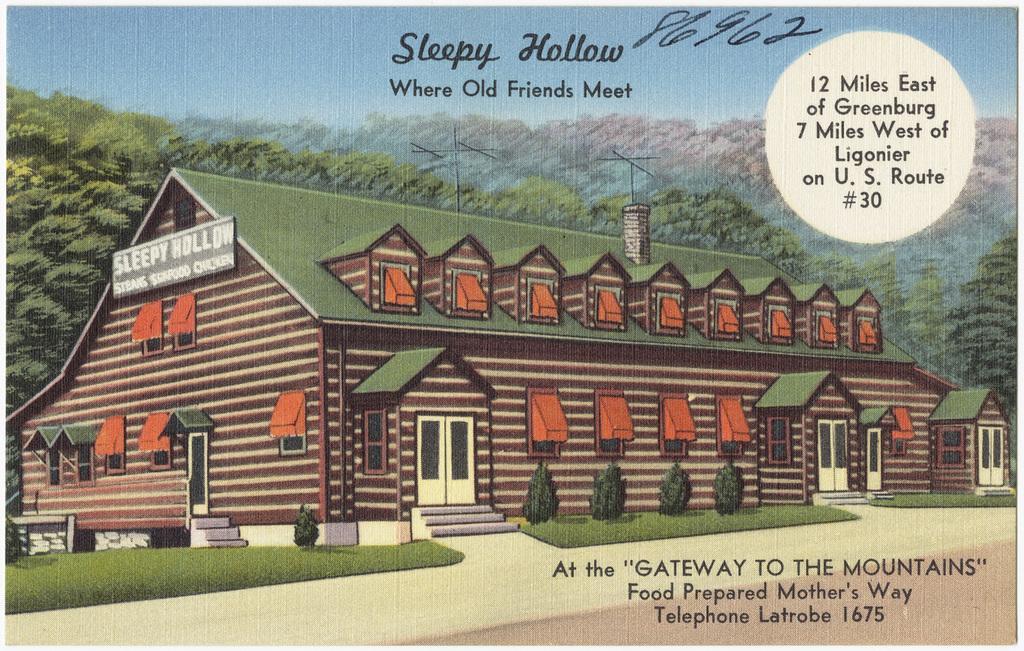Could you give a brief overview of what you see in this image? We can see poster,on this poster we can see building,grass and plants and we can see board on this building. In the background we can see trees and sky. We can see text. 